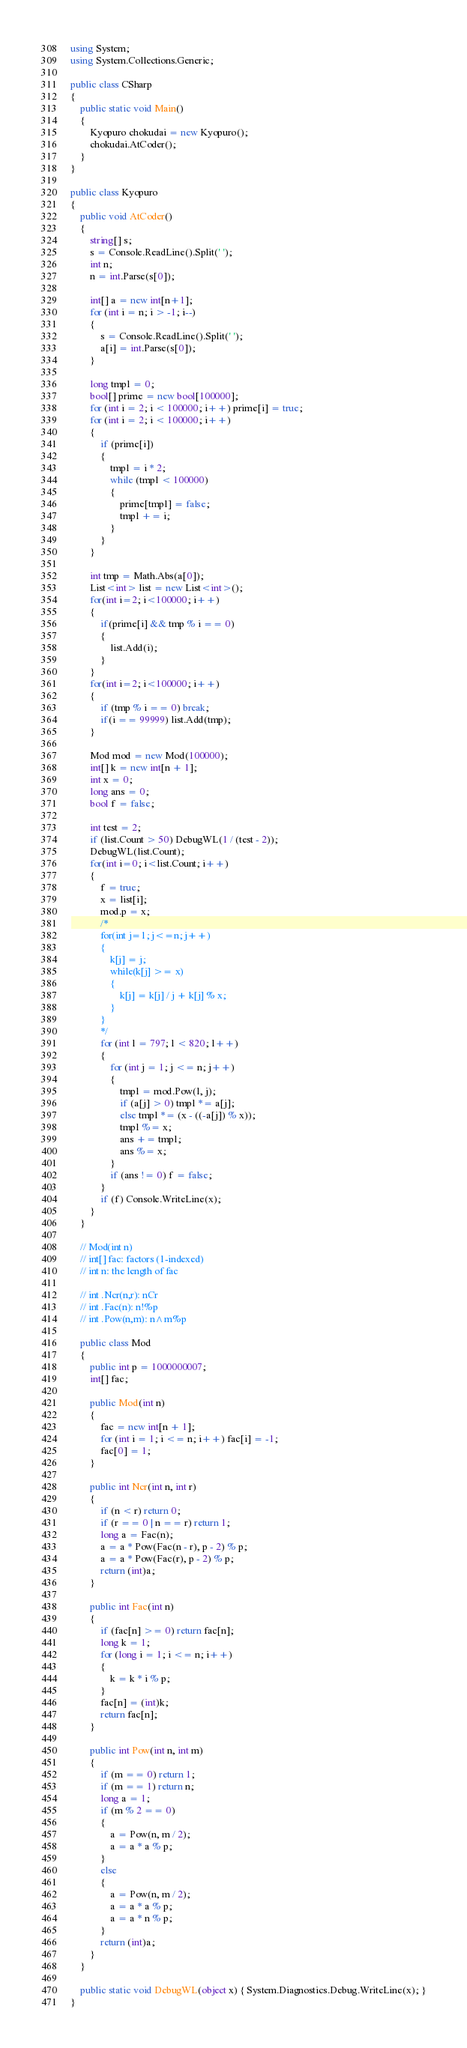Convert code to text. <code><loc_0><loc_0><loc_500><loc_500><_C#_>using System;
using System.Collections.Generic;

public class CSharp
{
    public static void Main()
    {
        Kyopuro chokudai = new Kyopuro();
        chokudai.AtCoder();
    }
}

public class Kyopuro
{
    public void AtCoder()
    {
        string[] s;
        s = Console.ReadLine().Split(' ');
        int n;
        n = int.Parse(s[0]);

        int[] a = new int[n+1];
        for (int i = n; i > -1; i--)
        {
            s = Console.ReadLine().Split(' ');
            a[i] = int.Parse(s[0]);
        }

        long tmpl = 0;
        bool[] prime = new bool[100000];
        for (int i = 2; i < 100000; i++) prime[i] = true;
        for (int i = 2; i < 100000; i++)
        {
            if (prime[i])
            {
                tmpl = i * 2;
                while (tmpl < 100000)
                {
                    prime[tmpl] = false;
                    tmpl += i;
                }
            }
        }

        int tmp = Math.Abs(a[0]);
        List<int> list = new List<int>();
        for(int i=2; i<100000; i++)
        {
            if(prime[i] && tmp % i == 0)
            {
                list.Add(i);
            }
        }
        for(int i=2; i<100000; i++)
        {
            if (tmp % i == 0) break;
            if(i == 99999) list.Add(tmp);
        }

        Mod mod = new Mod(100000);
        int[] k = new int[n + 1];
        int x = 0;
        long ans = 0;
        bool f = false;

        int test = 2;
        if (list.Count > 50) DebugWL(1 / (test - 2));
        DebugWL(list.Count);
        for(int i=0; i<list.Count; i++)
        {
            f = true;
            x = list[i];
            mod.p = x;
            /*
            for(int j=1; j<=n; j++)
            {
                k[j] = j;
                while(k[j] >= x)
                {
                    k[j] = k[j] / j + k[j] % x;
                }
            }
            */
            for (int l = 797; l < 820; l++)
            {
                for (int j = 1; j <= n; j++)
                {
                    tmpl = mod.Pow(l, j);
                    if (a[j] > 0) tmpl *= a[j];
                    else tmpl *= (x - ((-a[j]) % x));
                    tmpl %= x;
                    ans += tmpl;
                    ans %= x;                                
                }
                if (ans != 0) f = false;
            }
            if (f) Console.WriteLine(x);
        }
    }

    // Mod(int n)
    // int[] fac: factors (1-indexed)
    // int n: the length of fac

    // int .Ncr(n,r): nCr
    // int .Fac(n): n!%p
    // int .Pow(n,m): n^m%p

    public class Mod
    {
        public int p = 1000000007;
        int[] fac;

        public Mod(int n)
        {
            fac = new int[n + 1];
            for (int i = 1; i <= n; i++) fac[i] = -1;
            fac[0] = 1;
        }

        public int Ncr(int n, int r)
        {
            if (n < r) return 0;
            if (r == 0 | n == r) return 1;
            long a = Fac(n);
            a = a * Pow(Fac(n - r), p - 2) % p;
            a = a * Pow(Fac(r), p - 2) % p;
            return (int)a;
        }

        public int Fac(int n)
        {
            if (fac[n] >= 0) return fac[n];
            long k = 1;
            for (long i = 1; i <= n; i++)
            {
                k = k * i % p;
            }
            fac[n] = (int)k;
            return fac[n];
        }

        public int Pow(int n, int m)
        {
            if (m == 0) return 1;
            if (m == 1) return n;
            long a = 1;
            if (m % 2 == 0)
            {
                a = Pow(n, m / 2);
                a = a * a % p;
            }
            else
            {
                a = Pow(n, m / 2);
                a = a * a % p;
                a = a * n % p;
            }
            return (int)a;
        }
    }

    public static void DebugWL(object x) { System.Diagnostics.Debug.WriteLine(x); }
}
</code> 